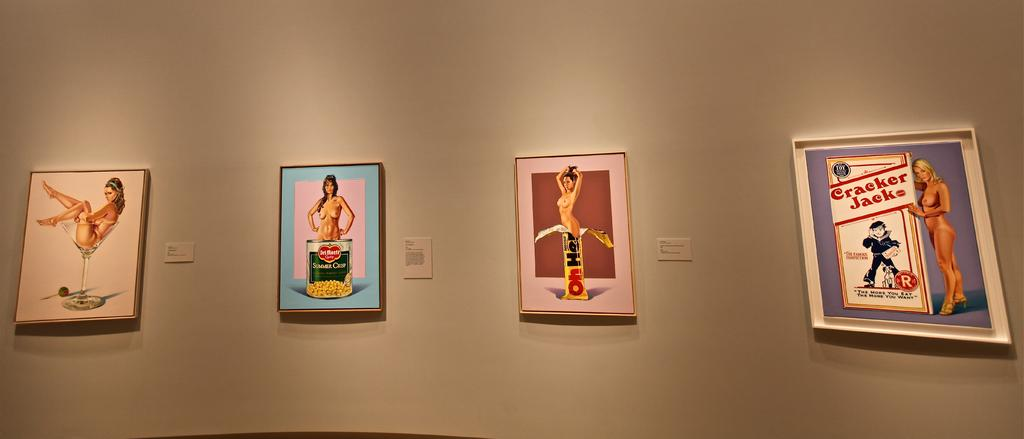<image>
Share a concise interpretation of the image provided. Four images from an art gallery, the right most image includes a box of cracker jacks. 